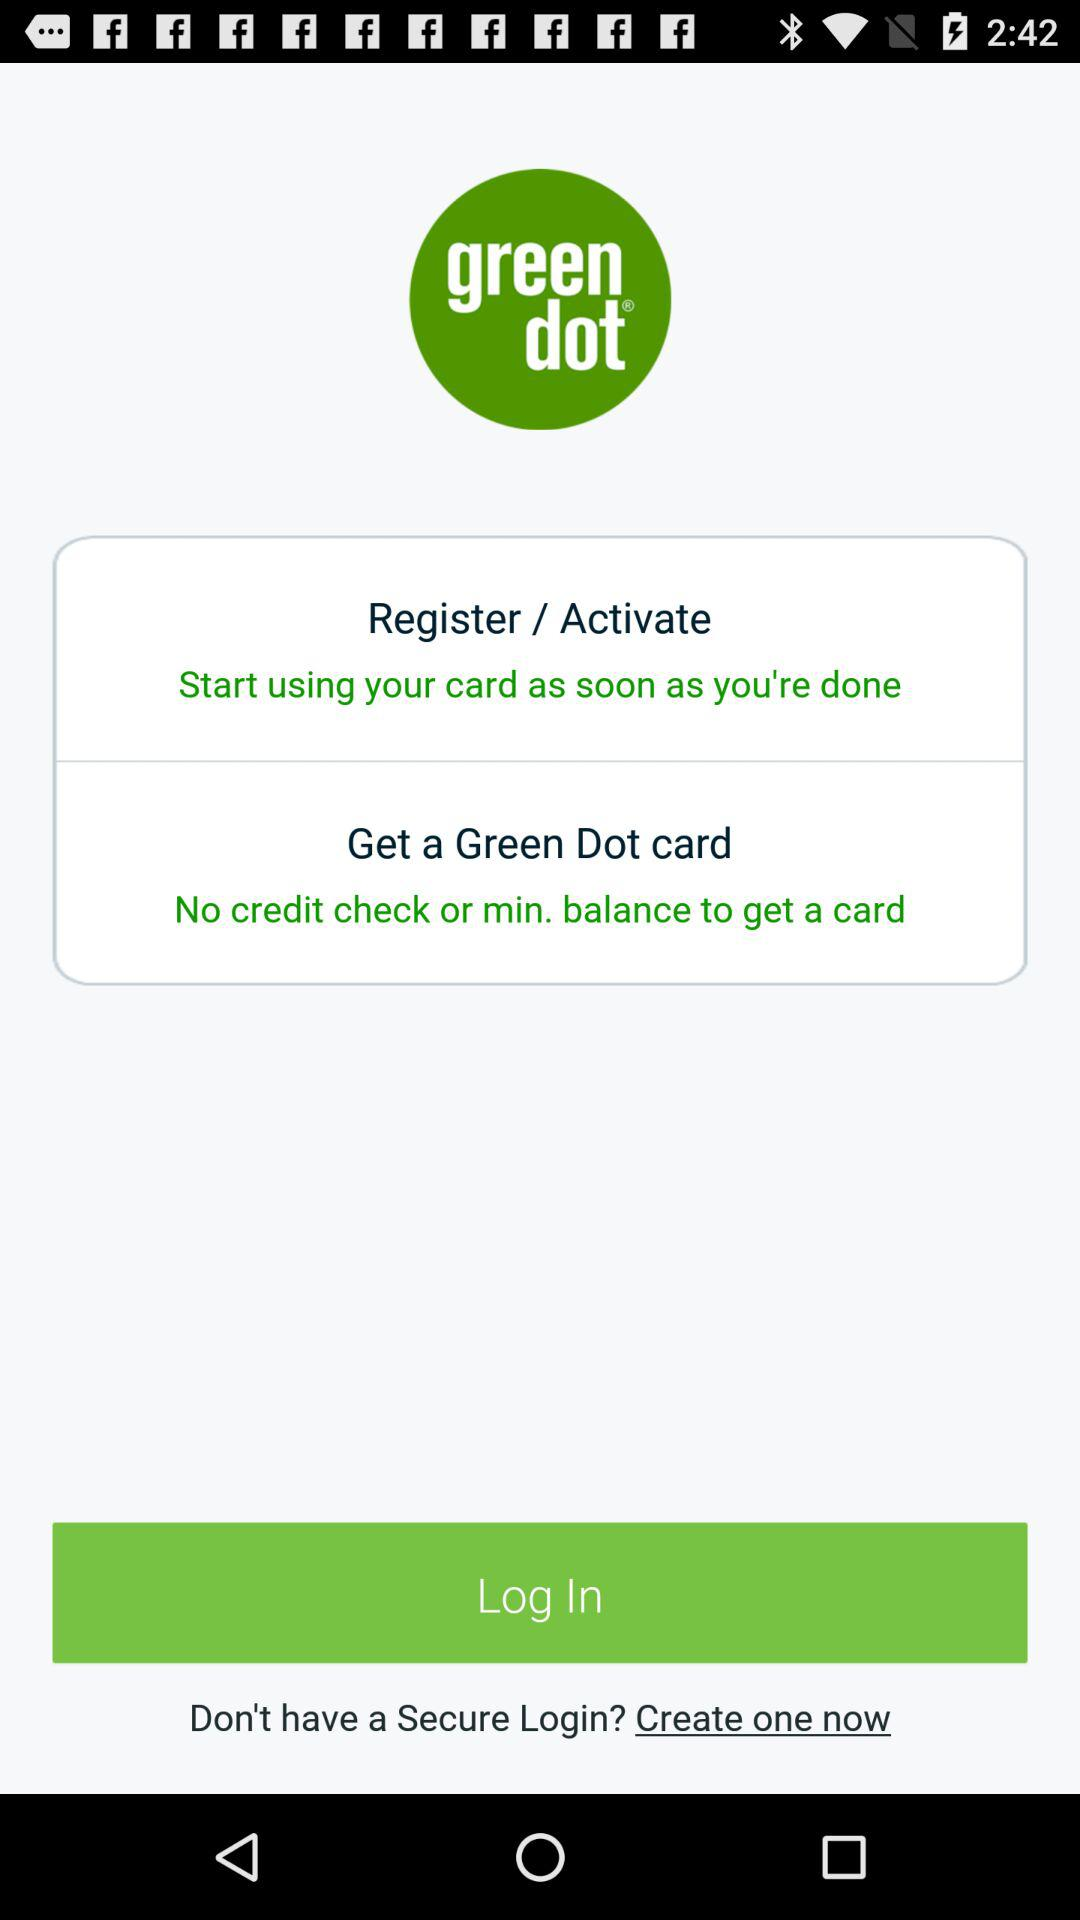What is the name of the application? The name of the application is "green dot". 